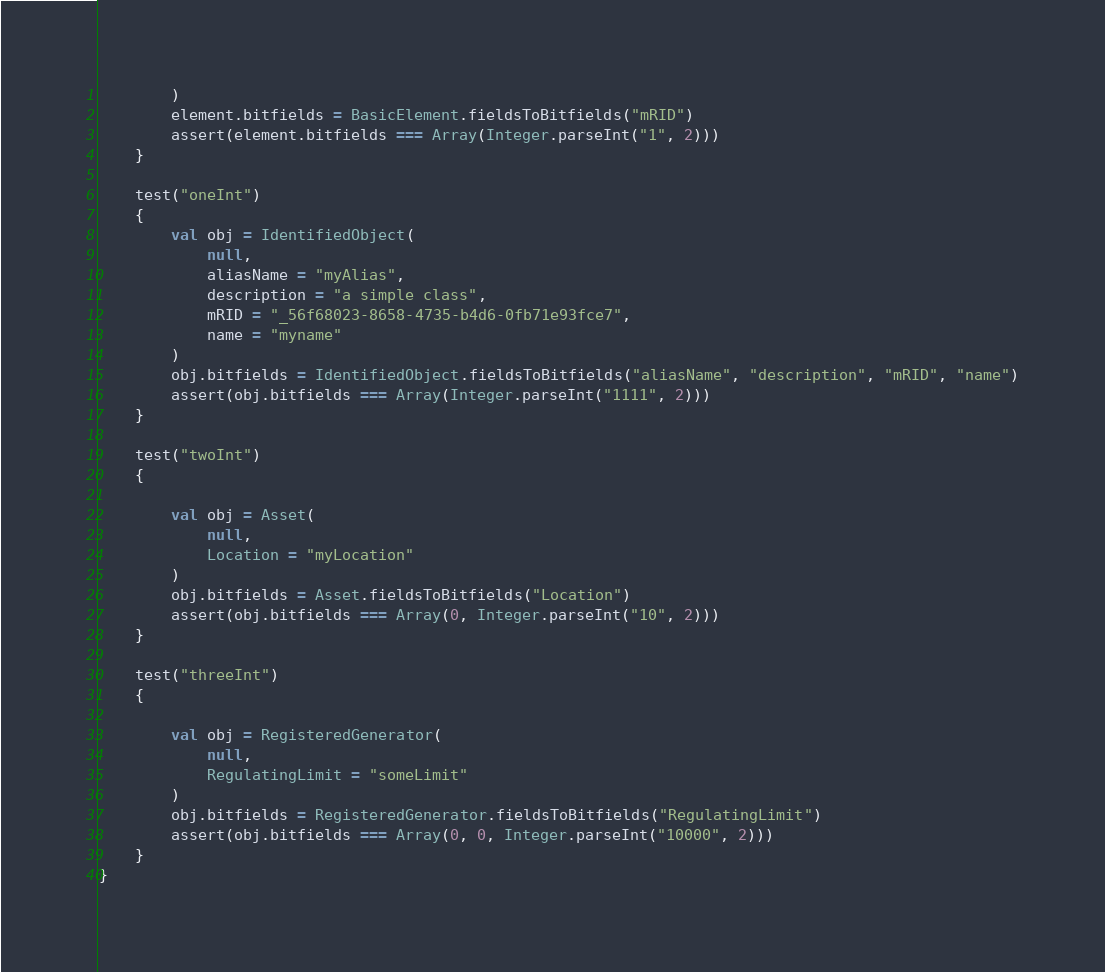<code> <loc_0><loc_0><loc_500><loc_500><_Scala_>        )
        element.bitfields = BasicElement.fieldsToBitfields("mRID")
        assert(element.bitfields === Array(Integer.parseInt("1", 2)))
    }

    test("oneInt")
    {
        val obj = IdentifiedObject(
            null,
            aliasName = "myAlias",
            description = "a simple class",
            mRID = "_56f68023-8658-4735-b4d6-0fb71e93fce7",
            name = "myname"
        )
        obj.bitfields = IdentifiedObject.fieldsToBitfields("aliasName", "description", "mRID", "name")
        assert(obj.bitfields === Array(Integer.parseInt("1111", 2)))
    }

    test("twoInt")
    {

        val obj = Asset(
            null,
            Location = "myLocation"
        )
        obj.bitfields = Asset.fieldsToBitfields("Location")
        assert(obj.bitfields === Array(0, Integer.parseInt("10", 2)))
    }

    test("threeInt")
    {

        val obj = RegisteredGenerator(
            null,
            RegulatingLimit = "someLimit"
        )
        obj.bitfields = RegisteredGenerator.fieldsToBitfields("RegulatingLimit")
        assert(obj.bitfields === Array(0, 0, Integer.parseInt("10000", 2)))
    }
}</code> 